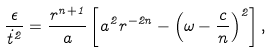Convert formula to latex. <formula><loc_0><loc_0><loc_500><loc_500>\frac { \epsilon } { \dot { t } ^ { 2 } } = \frac { r ^ { n + 1 } } { a } \left [ a ^ { 2 } r ^ { - 2 n } - \left ( \omega - \frac { c } { n } \right ) ^ { 2 } \right ] ,</formula> 